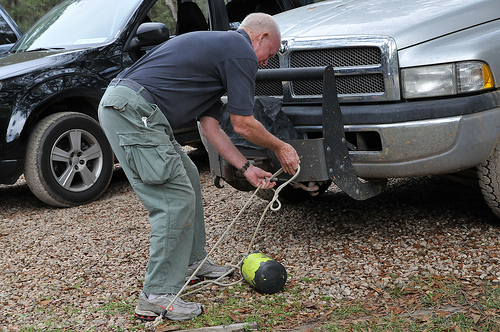What seems to be the purpose of the watermelon tied to the rope? The man seems to be using the watermelon as a weight or a counterbalance, possibly for a makeshift engineering or agricultural task. 